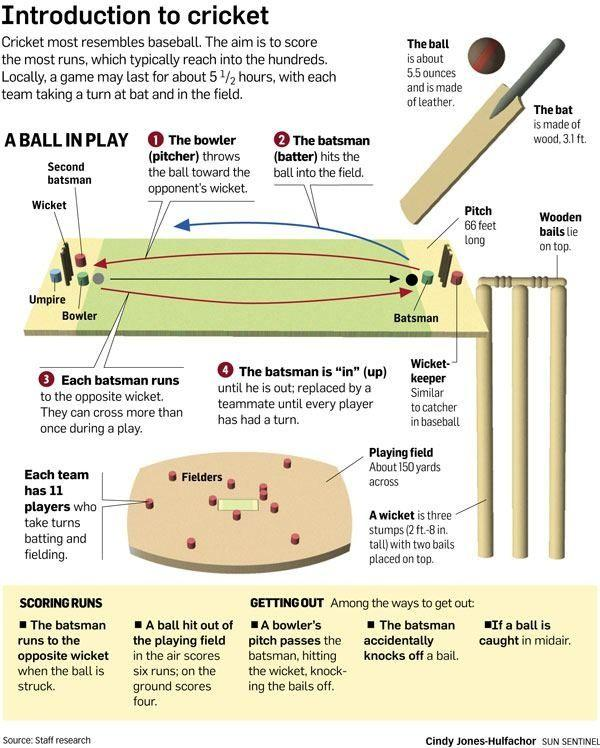Specify some key components in this picture. The color green was formerly used to represent bowler hats. The umpire was depicted using the color blue. 